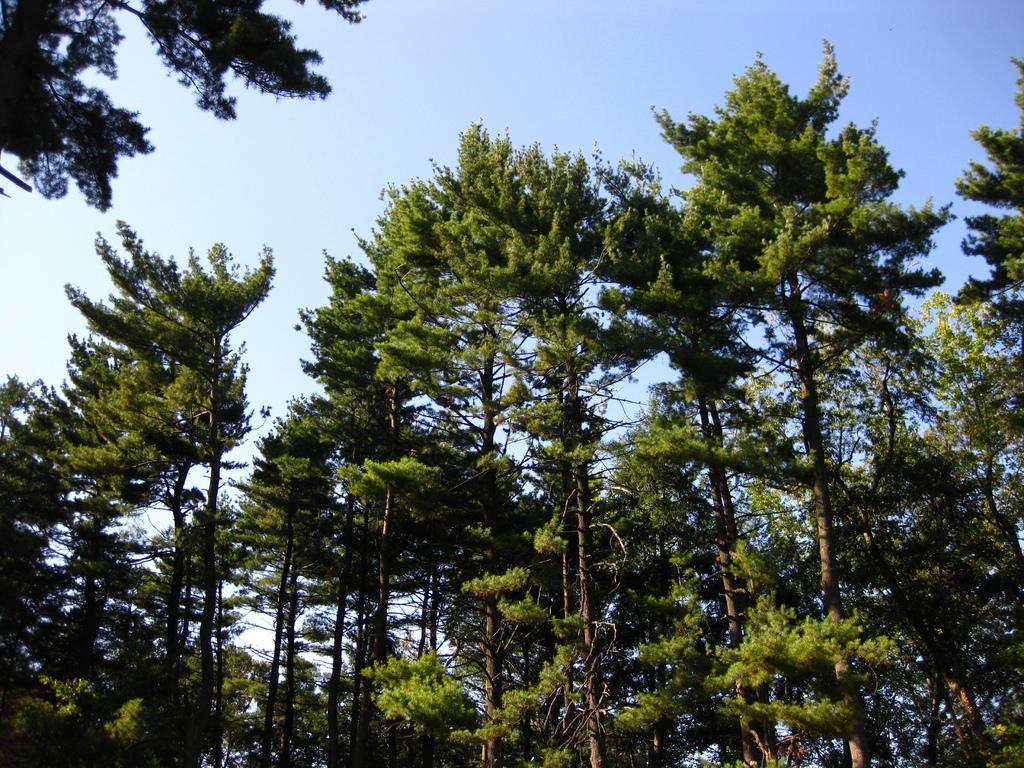Could you give a brief overview of what you see in this image? In this picture we can see a few trees from left to right. Sky is blue in color. 